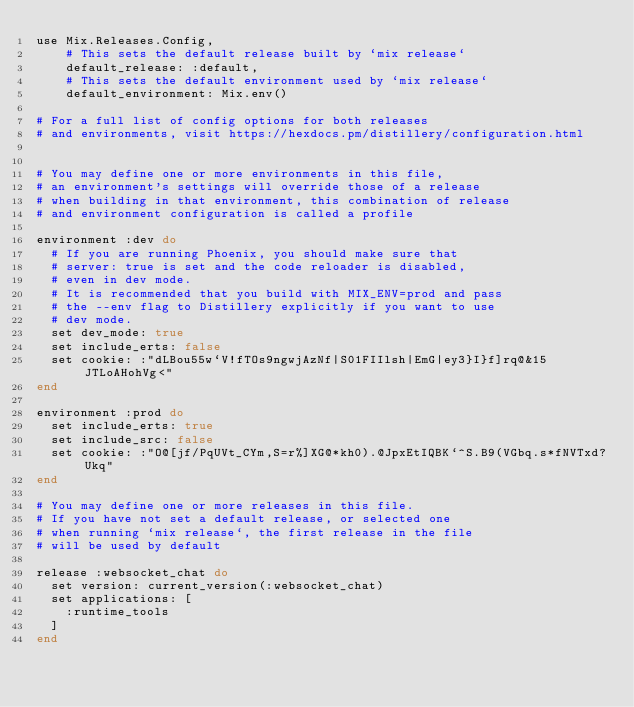<code> <loc_0><loc_0><loc_500><loc_500><_Elixir_>use Mix.Releases.Config,
    # This sets the default release built by `mix release`
    default_release: :default,
    # This sets the default environment used by `mix release`
    default_environment: Mix.env()

# For a full list of config options for both releases
# and environments, visit https://hexdocs.pm/distillery/configuration.html


# You may define one or more environments in this file,
# an environment's settings will override those of a release
# when building in that environment, this combination of release
# and environment configuration is called a profile

environment :dev do
  # If you are running Phoenix, you should make sure that
  # server: true is set and the code reloader is disabled,
  # even in dev mode.
  # It is recommended that you build with MIX_ENV=prod and pass
  # the --env flag to Distillery explicitly if you want to use
  # dev mode.
  set dev_mode: true
  set include_erts: false
  set cookie: :"dLBou55w`V!fTOs9ngwjAzNf|S01FIIlsh|EmG|ey3}I}f]rq@&15JTLoAHohVg<"
end

environment :prod do
  set include_erts: true
  set include_src: false
  set cookie: :"O@[jf/PqUVt_CYm,S=r%]XG@*kh0).@JpxEtIQBK`^S.B9(VGbq.s*fNVTxd?Ukq"
end

# You may define one or more releases in this file.
# If you have not set a default release, or selected one
# when running `mix release`, the first release in the file
# will be used by default

release :websocket_chat do
  set version: current_version(:websocket_chat)
  set applications: [
    :runtime_tools
  ]
end

</code> 